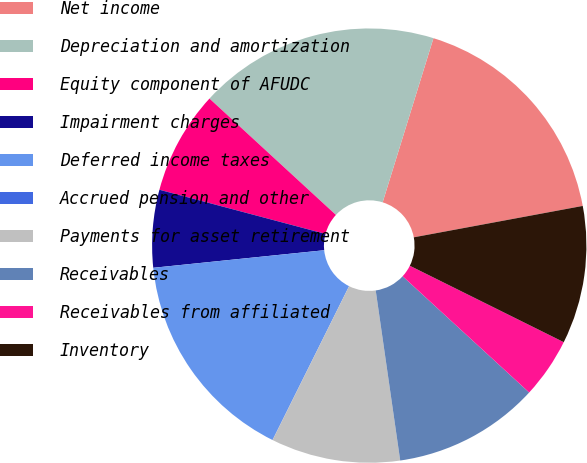Convert chart. <chart><loc_0><loc_0><loc_500><loc_500><pie_chart><fcel>Net income<fcel>Depreciation and amortization<fcel>Equity component of AFUDC<fcel>Impairment charges<fcel>Deferred income taxes<fcel>Accrued pension and other<fcel>Payments for asset retirement<fcel>Receivables<fcel>Receivables from affiliated<fcel>Inventory<nl><fcel>17.3%<fcel>17.94%<fcel>7.7%<fcel>5.77%<fcel>16.02%<fcel>0.01%<fcel>9.62%<fcel>10.9%<fcel>4.49%<fcel>10.26%<nl></chart> 